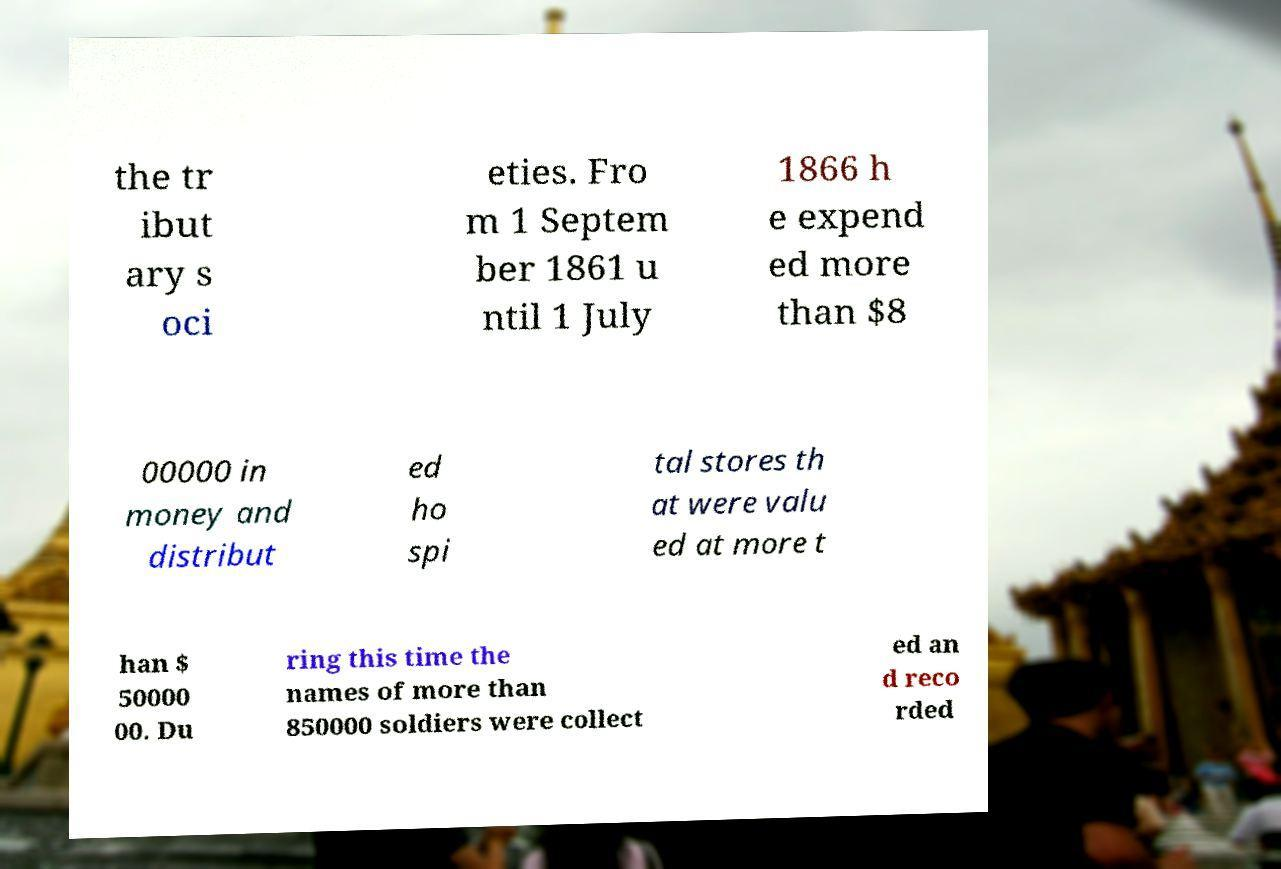What messages or text are displayed in this image? I need them in a readable, typed format. the tr ibut ary s oci eties. Fro m 1 Septem ber 1861 u ntil 1 July 1866 h e expend ed more than $8 00000 in money and distribut ed ho spi tal stores th at were valu ed at more t han $ 50000 00. Du ring this time the names of more than 850000 soldiers were collect ed an d reco rded 